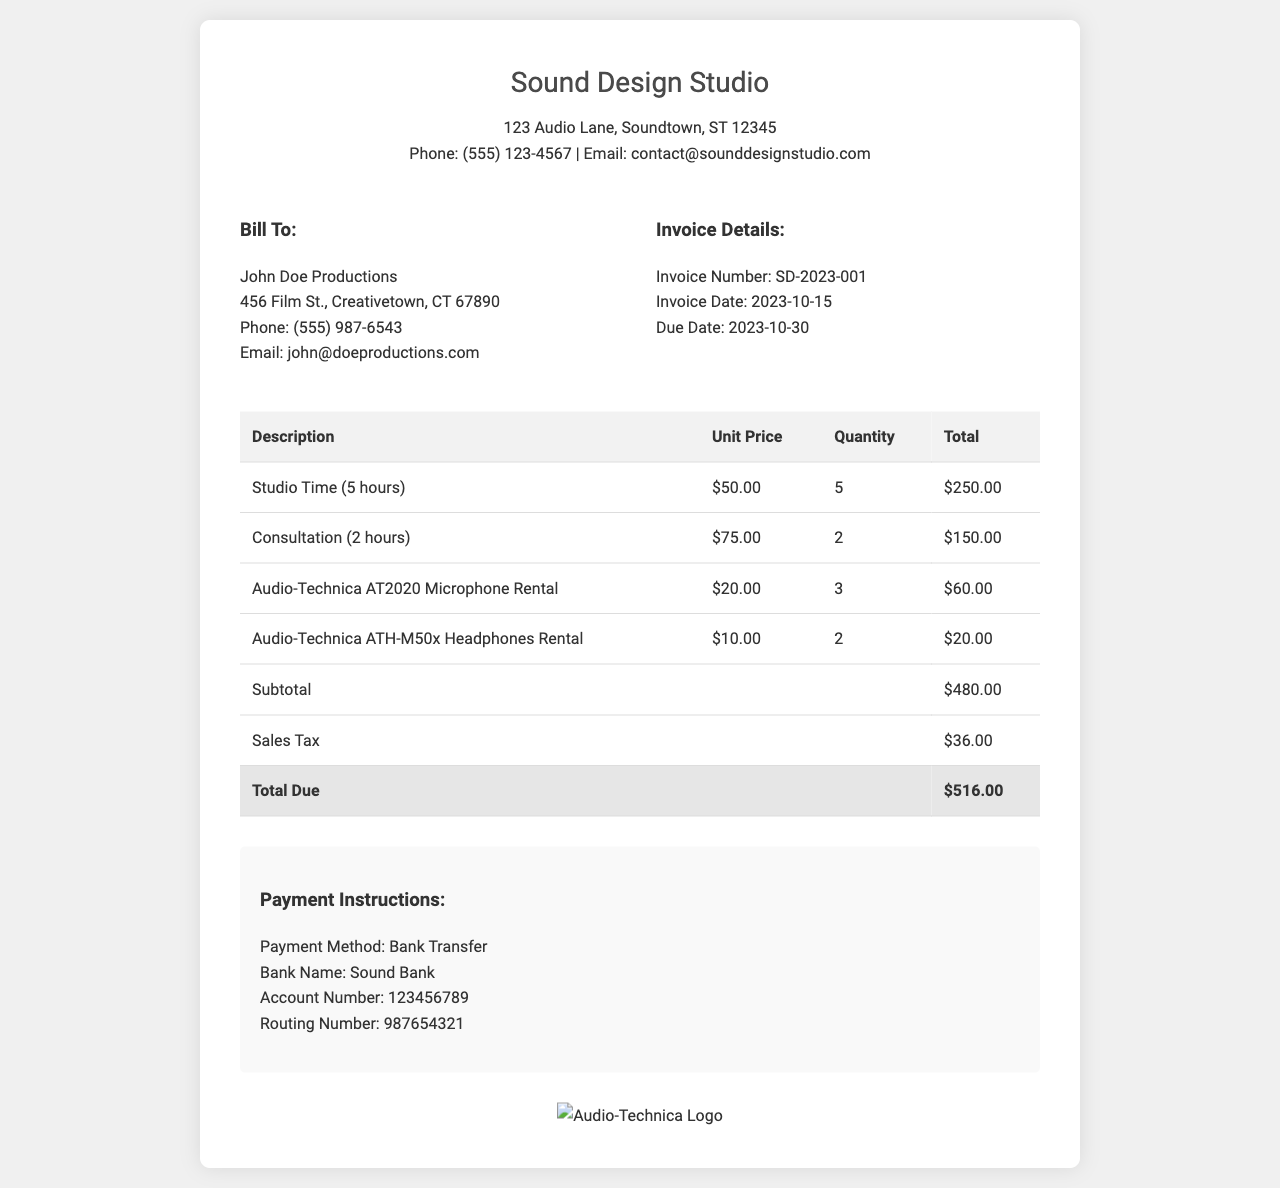What is the invoice number? The invoice number is provided in the invoice details section for reference, which is SD-2023-001.
Answer: SD-2023-001 What is the total due amount? The total due amount is calculated at the bottom of the table, summing up the subtotal and sales tax, which results in $516.00.
Answer: $516.00 Who is the client? The document specifies the billing information, which includes the client's name, John Doe Productions.
Answer: John Doe Productions How many hours of studio time were billed? According to the table, the billed studio time was for 5 hours.
Answer: 5 What is the unit price of the Audio-Technica AT2020 Microphone Rental? This detail is found in the table that lists the pricing for services and equipment, indicating the unit price is $20.00.
Answer: $20.00 What date is the invoice due? The due date for the invoice provides a specific timeline for payment, which is stated as 2023-10-30.
Answer: 2023-10-30 What is the total sales tax amount? The sales tax is clearly listed in the invoice table and is calculated to be $36.00.
Answer: $36.00 Which payment method is specified? The payment instructions section outlines how payments can be made, stating that the method is Bank Transfer.
Answer: Bank Transfer How many Audio-Technica ATH-M50x Headphones were rented? The equipment rental details in the table specify that 2 sets of the headphones were rented.
Answer: 2 